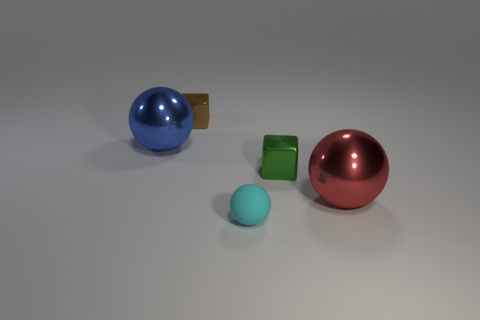There is a big object left of the small cube that is behind the blue shiny object; what is its color?
Provide a short and direct response. Blue. How many small cubes are there?
Offer a terse response. 2. Are there fewer big red things that are behind the blue thing than big red objects that are left of the small cyan thing?
Keep it short and to the point. No. The tiny matte sphere is what color?
Provide a succinct answer. Cyan. There is a small green thing; are there any brown metallic things right of it?
Give a very brief answer. No. Are there an equal number of big things that are in front of the small cyan matte object and big red metal spheres that are left of the red shiny sphere?
Provide a succinct answer. Yes. There is a shiny cube that is on the right side of the brown block; is it the same size as the shiny thing that is on the left side of the brown shiny block?
Your response must be concise. No. What shape is the big metal object in front of the ball that is behind the tiny block on the right side of the cyan ball?
Provide a succinct answer. Sphere. Are there any other things that are made of the same material as the tiny brown thing?
Offer a terse response. Yes. What is the size of the red metallic thing that is the same shape as the big blue metal object?
Ensure brevity in your answer.  Large. 